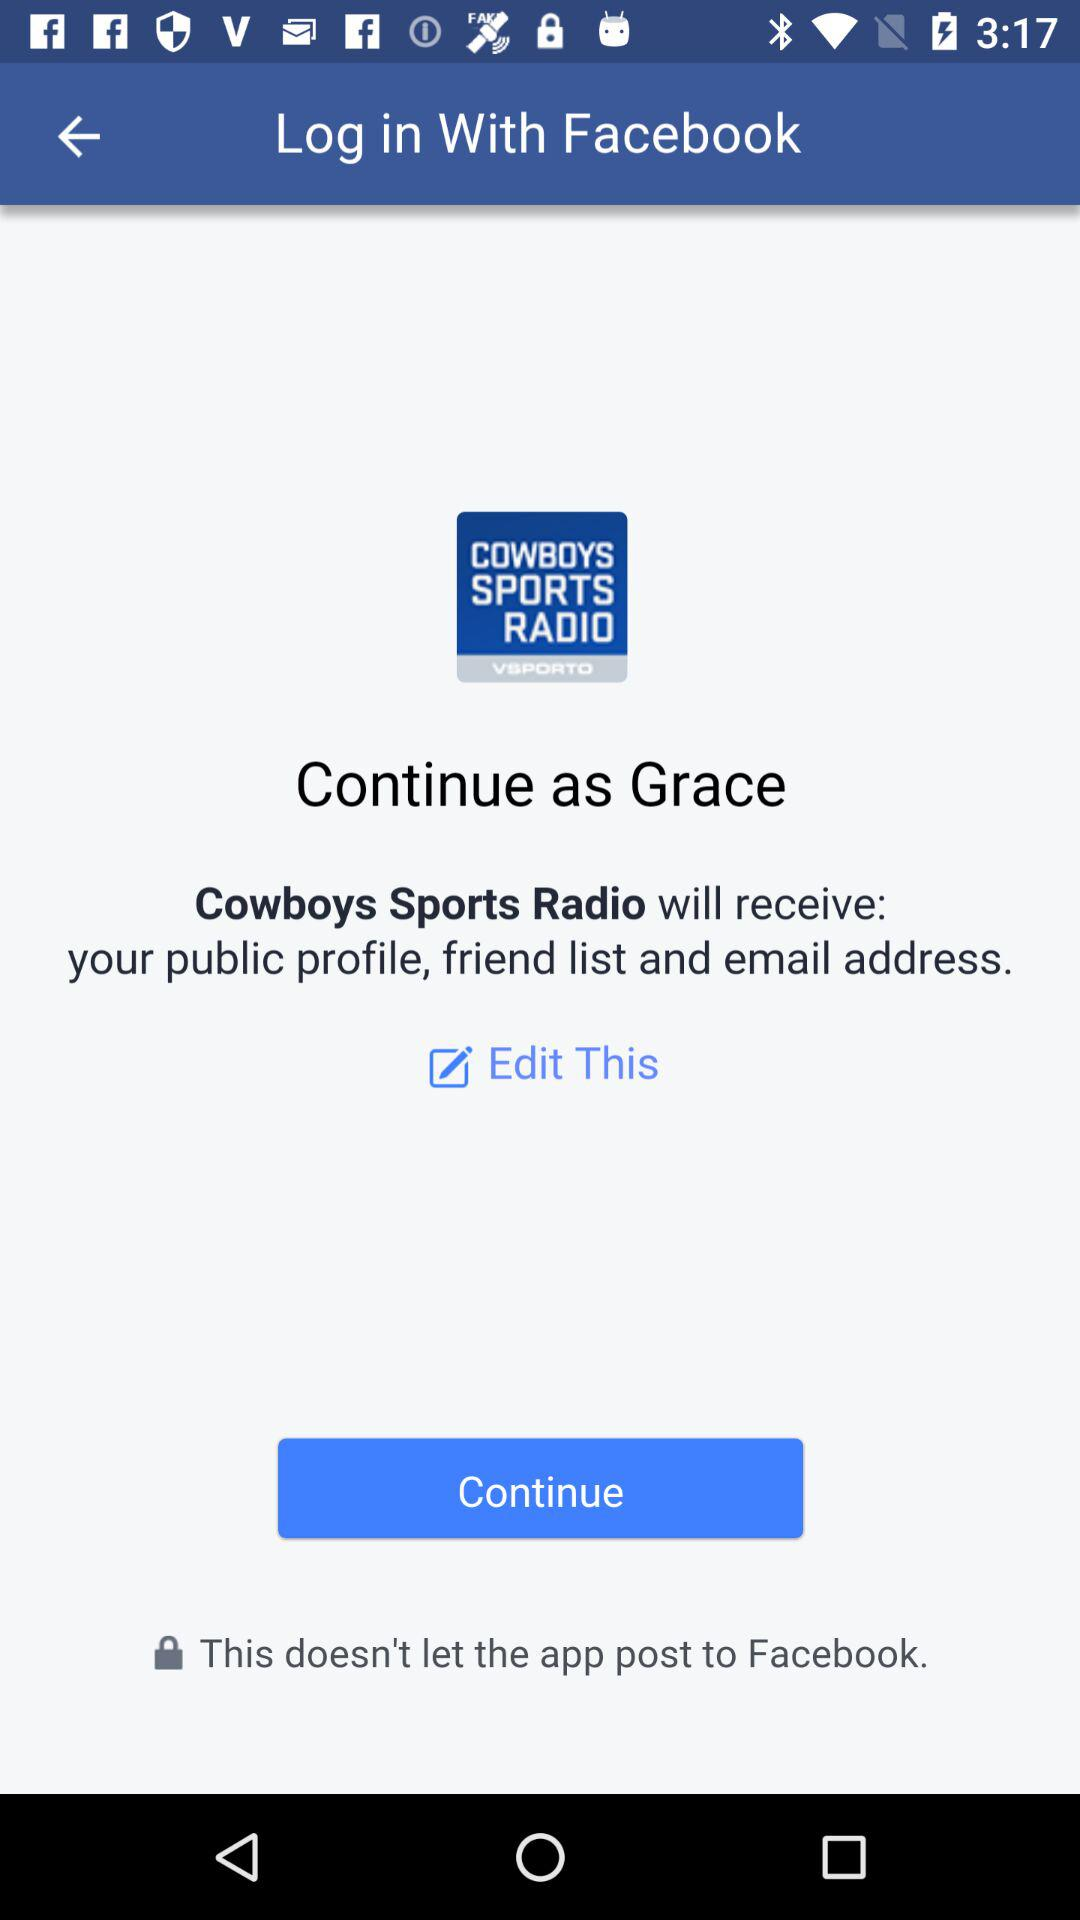What is the user name? The user name is Grace. 